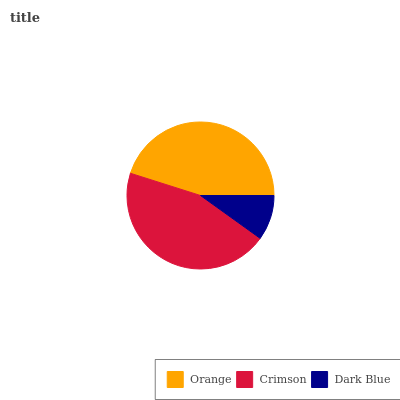Is Dark Blue the minimum?
Answer yes or no. Yes. Is Orange the maximum?
Answer yes or no. Yes. Is Crimson the minimum?
Answer yes or no. No. Is Crimson the maximum?
Answer yes or no. No. Is Orange greater than Crimson?
Answer yes or no. Yes. Is Crimson less than Orange?
Answer yes or no. Yes. Is Crimson greater than Orange?
Answer yes or no. No. Is Orange less than Crimson?
Answer yes or no. No. Is Crimson the high median?
Answer yes or no. Yes. Is Crimson the low median?
Answer yes or no. Yes. Is Dark Blue the high median?
Answer yes or no. No. Is Orange the low median?
Answer yes or no. No. 